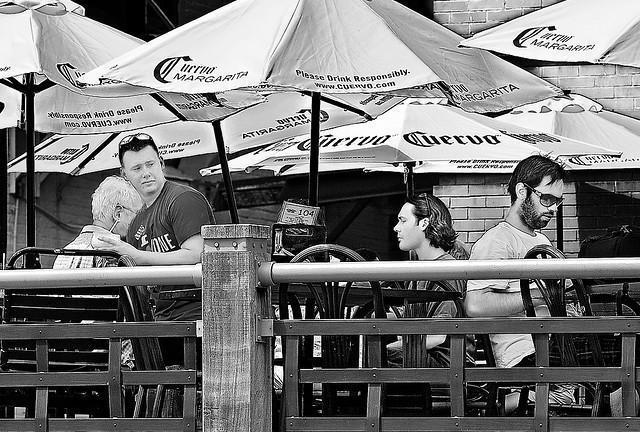How many people are there?
Give a very brief answer. 4. How many people have beards?
Give a very brief answer. 1. How many umbrellas are there?
Give a very brief answer. 5. How many chairs can be seen?
Give a very brief answer. 3. How many grey bears are in the picture?
Give a very brief answer. 0. 